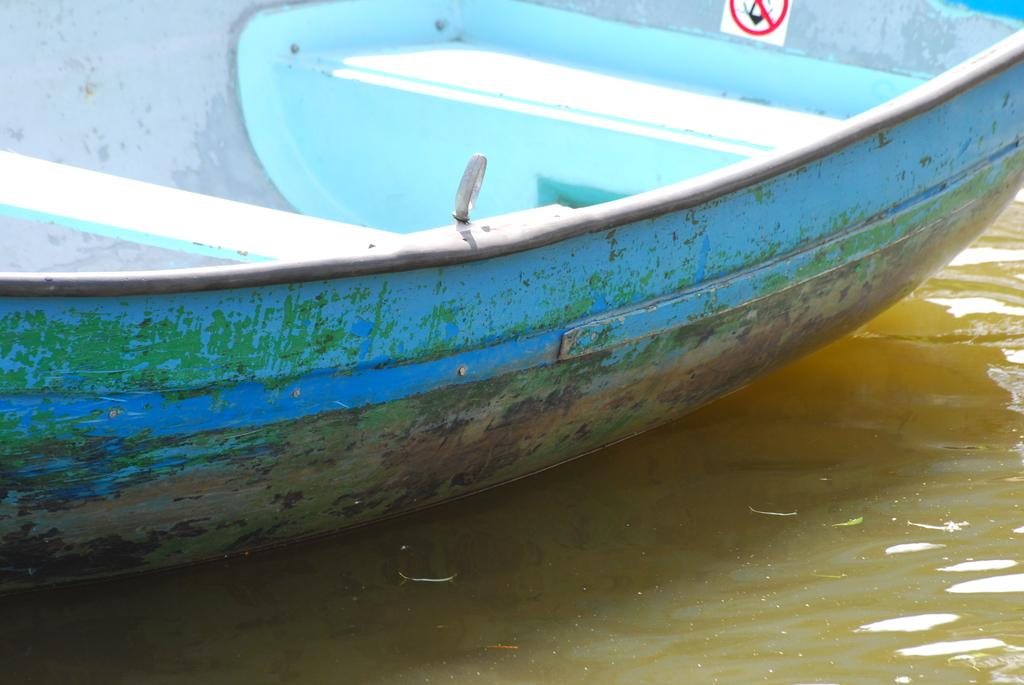What is the main subject of the image? The main subject of the image is a boat. What else can be seen in the image besides the boat? There is a paper with a sign in the image. What is the setting of the image? There is water visible in the image. What type of jeans can be seen hanging on the boat in the image? There are no jeans present in the image; it only features a boat, a paper with a sign, and water. 